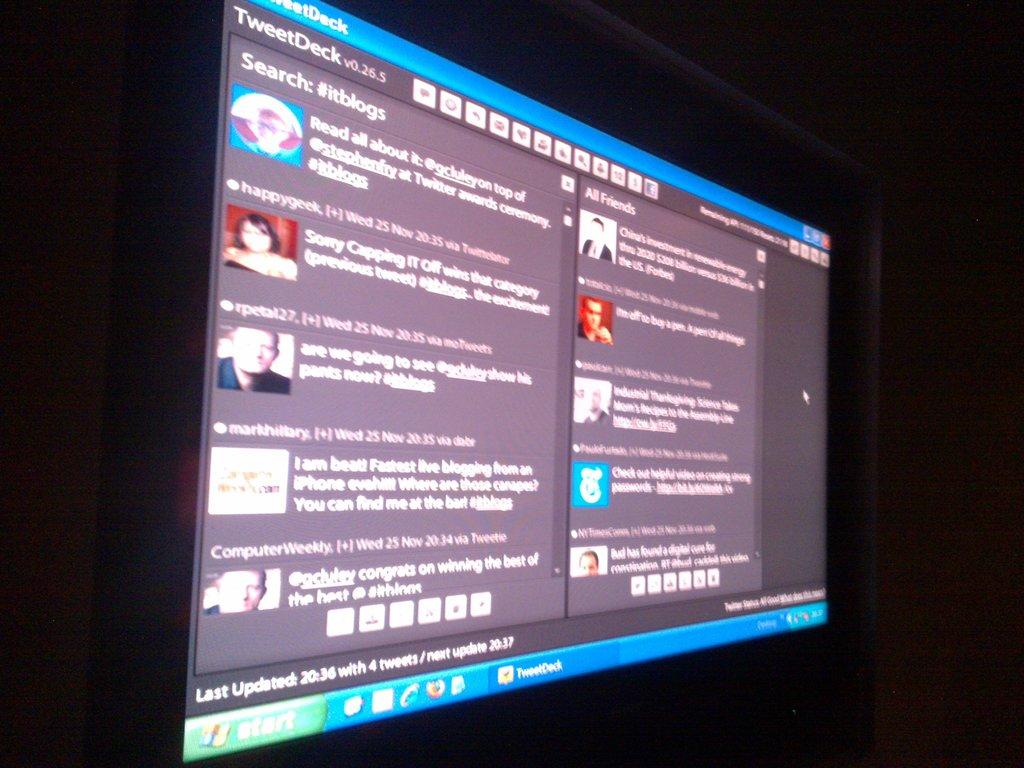Which app is being used?
Your answer should be compact. Tweetdeck. 